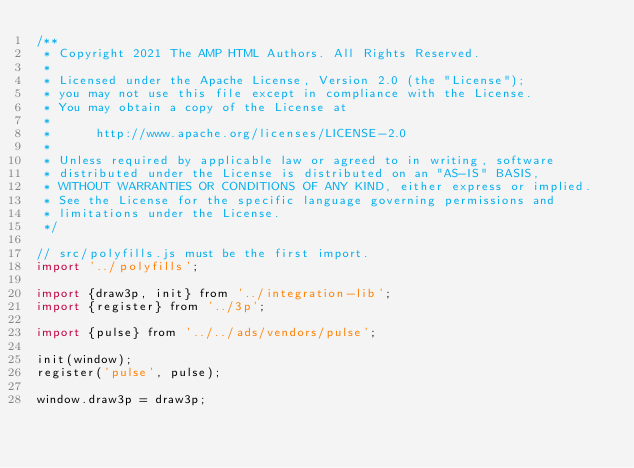Convert code to text. <code><loc_0><loc_0><loc_500><loc_500><_JavaScript_>/**
 * Copyright 2021 The AMP HTML Authors. All Rights Reserved.
 *
 * Licensed under the Apache License, Version 2.0 (the "License");
 * you may not use this file except in compliance with the License.
 * You may obtain a copy of the License at
 *
 *      http://www.apache.org/licenses/LICENSE-2.0
 *
 * Unless required by applicable law or agreed to in writing, software
 * distributed under the License is distributed on an "AS-IS" BASIS,
 * WITHOUT WARRANTIES OR CONDITIONS OF ANY KIND, either express or implied.
 * See the License for the specific language governing permissions and
 * limitations under the License.
 */

// src/polyfills.js must be the first import.
import '../polyfills';

import {draw3p, init} from '../integration-lib';
import {register} from '../3p';

import {pulse} from '../../ads/vendors/pulse';

init(window);
register('pulse', pulse);

window.draw3p = draw3p;
</code> 